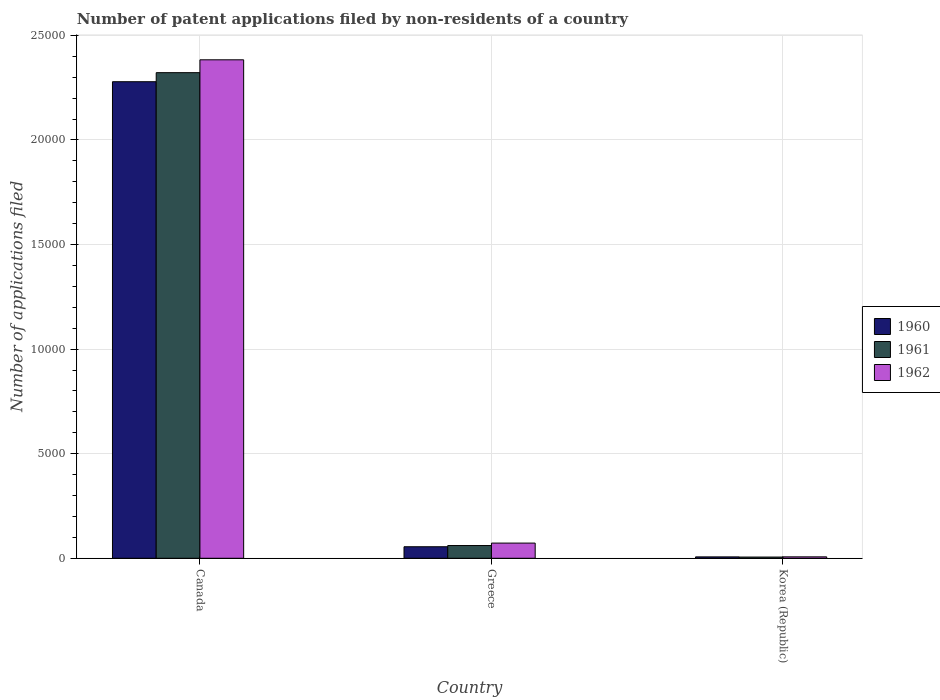Are the number of bars per tick equal to the number of legend labels?
Provide a short and direct response. Yes. How many bars are there on the 2nd tick from the right?
Offer a terse response. 3. What is the label of the 2nd group of bars from the left?
Your response must be concise. Greece. What is the number of applications filed in 1960 in Greece?
Give a very brief answer. 551. Across all countries, what is the maximum number of applications filed in 1962?
Your response must be concise. 2.38e+04. In which country was the number of applications filed in 1962 maximum?
Your answer should be compact. Canada. What is the total number of applications filed in 1962 in the graph?
Make the answer very short. 2.46e+04. What is the difference between the number of applications filed in 1961 in Canada and that in Korea (Republic)?
Ensure brevity in your answer.  2.32e+04. What is the difference between the number of applications filed in 1960 in Canada and the number of applications filed in 1961 in Korea (Republic)?
Give a very brief answer. 2.27e+04. What is the average number of applications filed in 1960 per country?
Offer a terse response. 7801. In how many countries, is the number of applications filed in 1960 greater than 5000?
Your response must be concise. 1. What is the ratio of the number of applications filed in 1960 in Canada to that in Korea (Republic)?
Offer a very short reply. 345.24. Is the difference between the number of applications filed in 1962 in Canada and Greece greater than the difference between the number of applications filed in 1961 in Canada and Greece?
Your answer should be very brief. Yes. What is the difference between the highest and the second highest number of applications filed in 1962?
Offer a terse response. 2.38e+04. What is the difference between the highest and the lowest number of applications filed in 1962?
Make the answer very short. 2.38e+04. In how many countries, is the number of applications filed in 1960 greater than the average number of applications filed in 1960 taken over all countries?
Your answer should be compact. 1. Is the sum of the number of applications filed in 1960 in Greece and Korea (Republic) greater than the maximum number of applications filed in 1962 across all countries?
Keep it short and to the point. No. What does the 1st bar from the left in Canada represents?
Provide a short and direct response. 1960. What does the 3rd bar from the right in Canada represents?
Offer a very short reply. 1960. How many bars are there?
Ensure brevity in your answer.  9. Are all the bars in the graph horizontal?
Your answer should be very brief. No. What is the difference between two consecutive major ticks on the Y-axis?
Provide a short and direct response. 5000. Does the graph contain grids?
Offer a terse response. Yes. Where does the legend appear in the graph?
Provide a succinct answer. Center right. What is the title of the graph?
Your answer should be compact. Number of patent applications filed by non-residents of a country. Does "1963" appear as one of the legend labels in the graph?
Ensure brevity in your answer.  No. What is the label or title of the Y-axis?
Provide a succinct answer. Number of applications filed. What is the Number of applications filed of 1960 in Canada?
Provide a succinct answer. 2.28e+04. What is the Number of applications filed of 1961 in Canada?
Your response must be concise. 2.32e+04. What is the Number of applications filed of 1962 in Canada?
Keep it short and to the point. 2.38e+04. What is the Number of applications filed of 1960 in Greece?
Make the answer very short. 551. What is the Number of applications filed of 1961 in Greece?
Your answer should be compact. 609. What is the Number of applications filed in 1962 in Greece?
Your response must be concise. 726. What is the Number of applications filed in 1960 in Korea (Republic)?
Provide a succinct answer. 66. What is the Number of applications filed in 1962 in Korea (Republic)?
Make the answer very short. 68. Across all countries, what is the maximum Number of applications filed in 1960?
Give a very brief answer. 2.28e+04. Across all countries, what is the maximum Number of applications filed in 1961?
Keep it short and to the point. 2.32e+04. Across all countries, what is the maximum Number of applications filed of 1962?
Your answer should be compact. 2.38e+04. Across all countries, what is the minimum Number of applications filed of 1961?
Your answer should be compact. 58. Across all countries, what is the minimum Number of applications filed in 1962?
Give a very brief answer. 68. What is the total Number of applications filed in 1960 in the graph?
Your answer should be compact. 2.34e+04. What is the total Number of applications filed of 1961 in the graph?
Provide a short and direct response. 2.39e+04. What is the total Number of applications filed in 1962 in the graph?
Your answer should be compact. 2.46e+04. What is the difference between the Number of applications filed of 1960 in Canada and that in Greece?
Ensure brevity in your answer.  2.22e+04. What is the difference between the Number of applications filed of 1961 in Canada and that in Greece?
Your response must be concise. 2.26e+04. What is the difference between the Number of applications filed of 1962 in Canada and that in Greece?
Offer a very short reply. 2.31e+04. What is the difference between the Number of applications filed in 1960 in Canada and that in Korea (Republic)?
Your answer should be compact. 2.27e+04. What is the difference between the Number of applications filed of 1961 in Canada and that in Korea (Republic)?
Offer a very short reply. 2.32e+04. What is the difference between the Number of applications filed of 1962 in Canada and that in Korea (Republic)?
Give a very brief answer. 2.38e+04. What is the difference between the Number of applications filed of 1960 in Greece and that in Korea (Republic)?
Give a very brief answer. 485. What is the difference between the Number of applications filed in 1961 in Greece and that in Korea (Republic)?
Offer a terse response. 551. What is the difference between the Number of applications filed in 1962 in Greece and that in Korea (Republic)?
Offer a terse response. 658. What is the difference between the Number of applications filed in 1960 in Canada and the Number of applications filed in 1961 in Greece?
Your response must be concise. 2.22e+04. What is the difference between the Number of applications filed in 1960 in Canada and the Number of applications filed in 1962 in Greece?
Offer a very short reply. 2.21e+04. What is the difference between the Number of applications filed in 1961 in Canada and the Number of applications filed in 1962 in Greece?
Keep it short and to the point. 2.25e+04. What is the difference between the Number of applications filed in 1960 in Canada and the Number of applications filed in 1961 in Korea (Republic)?
Provide a short and direct response. 2.27e+04. What is the difference between the Number of applications filed in 1960 in Canada and the Number of applications filed in 1962 in Korea (Republic)?
Your response must be concise. 2.27e+04. What is the difference between the Number of applications filed in 1961 in Canada and the Number of applications filed in 1962 in Korea (Republic)?
Give a very brief answer. 2.32e+04. What is the difference between the Number of applications filed of 1960 in Greece and the Number of applications filed of 1961 in Korea (Republic)?
Give a very brief answer. 493. What is the difference between the Number of applications filed in 1960 in Greece and the Number of applications filed in 1962 in Korea (Republic)?
Ensure brevity in your answer.  483. What is the difference between the Number of applications filed of 1961 in Greece and the Number of applications filed of 1962 in Korea (Republic)?
Ensure brevity in your answer.  541. What is the average Number of applications filed in 1960 per country?
Your answer should be compact. 7801. What is the average Number of applications filed of 1961 per country?
Make the answer very short. 7962. What is the average Number of applications filed of 1962 per country?
Your answer should be compact. 8209.33. What is the difference between the Number of applications filed in 1960 and Number of applications filed in 1961 in Canada?
Your answer should be compact. -433. What is the difference between the Number of applications filed of 1960 and Number of applications filed of 1962 in Canada?
Give a very brief answer. -1048. What is the difference between the Number of applications filed of 1961 and Number of applications filed of 1962 in Canada?
Ensure brevity in your answer.  -615. What is the difference between the Number of applications filed in 1960 and Number of applications filed in 1961 in Greece?
Provide a short and direct response. -58. What is the difference between the Number of applications filed in 1960 and Number of applications filed in 1962 in Greece?
Make the answer very short. -175. What is the difference between the Number of applications filed of 1961 and Number of applications filed of 1962 in Greece?
Provide a succinct answer. -117. What is the difference between the Number of applications filed of 1960 and Number of applications filed of 1961 in Korea (Republic)?
Provide a succinct answer. 8. What is the difference between the Number of applications filed in 1960 and Number of applications filed in 1962 in Korea (Republic)?
Offer a terse response. -2. What is the ratio of the Number of applications filed in 1960 in Canada to that in Greece?
Provide a short and direct response. 41.35. What is the ratio of the Number of applications filed in 1961 in Canada to that in Greece?
Provide a short and direct response. 38.13. What is the ratio of the Number of applications filed of 1962 in Canada to that in Greece?
Ensure brevity in your answer.  32.83. What is the ratio of the Number of applications filed of 1960 in Canada to that in Korea (Republic)?
Provide a short and direct response. 345.24. What is the ratio of the Number of applications filed of 1961 in Canada to that in Korea (Republic)?
Your response must be concise. 400.33. What is the ratio of the Number of applications filed in 1962 in Canada to that in Korea (Republic)?
Provide a succinct answer. 350.5. What is the ratio of the Number of applications filed of 1960 in Greece to that in Korea (Republic)?
Offer a very short reply. 8.35. What is the ratio of the Number of applications filed in 1961 in Greece to that in Korea (Republic)?
Keep it short and to the point. 10.5. What is the ratio of the Number of applications filed of 1962 in Greece to that in Korea (Republic)?
Keep it short and to the point. 10.68. What is the difference between the highest and the second highest Number of applications filed in 1960?
Make the answer very short. 2.22e+04. What is the difference between the highest and the second highest Number of applications filed in 1961?
Your answer should be very brief. 2.26e+04. What is the difference between the highest and the second highest Number of applications filed in 1962?
Your response must be concise. 2.31e+04. What is the difference between the highest and the lowest Number of applications filed of 1960?
Give a very brief answer. 2.27e+04. What is the difference between the highest and the lowest Number of applications filed of 1961?
Offer a very short reply. 2.32e+04. What is the difference between the highest and the lowest Number of applications filed in 1962?
Provide a short and direct response. 2.38e+04. 